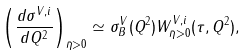<formula> <loc_0><loc_0><loc_500><loc_500>\left ( { \frac { d \sigma ^ { V , i } } { d Q ^ { 2 } } } \right ) _ { { \bar { \eta } } > 0 } \simeq \sigma _ { B } ^ { V } ( Q ^ { 2 } ) W _ { { \bar { \eta } } > 0 } ^ { V , i } ( \tau , Q ^ { 2 } ) ,</formula> 